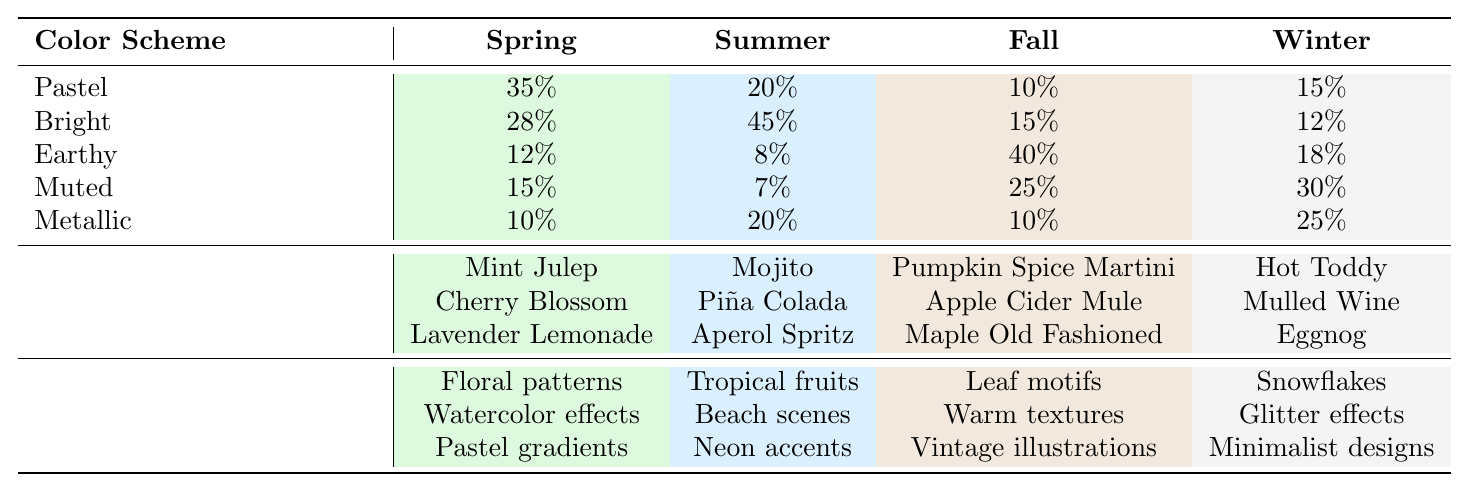What is the most popular color scheme for Spring? The table shows that the "Pastel" color scheme has the highest percentage at 35% for Spring.
Answer: Pastel Which color scheme is least popular in the Summer? From the table, "Muted" is the least popular color scheme with a percentage of 7% for Summer.
Answer: Muted How many total color schemes are represented in the table? There are five color schemes listed: Pastel, Bright, Earthy, Muted, and Metallic. Thus, the total is 5.
Answer: 5 What is the difference in popularity between the Bright color scheme in Summer and Fall? The Bright color scheme is 45% in Summer and 15% in Fall, so the difference is 45 - 15 = 30%.
Answer: 30% What color scheme is the most popular in Winter? According to the table, "Muted" has the highest percentage at 30% in Winter.
Answer: Muted What is the average popularity of the Earthy color scheme across all four seasons? Adding the percentages for Earthy: 12% (Spring) + 8% (Summer) + 40% (Fall) + 18% (Winter) = 78%. Then, dividing by 4 gives an average of 78 / 4 = 19.5%.
Answer: 19.5% Which season has the highest percentage of Bright color schemes and what is that percentage? The table indicates that Summer has the highest percentage of Bright at 45%.
Answer: Summer, 45% Is the Metallic color scheme more popular in Winter than in Spring? In Winter, the Metallic percentage is 25% while in Spring, it is 10%. Since 25% is greater than 10%, the statement is true.
Answer: Yes Which season has the lowest usage of Pastel color schemes and what is the percentage? The table shows that Fall has the lowest usage with only 10% for the Pastel color scheme.
Answer: Fall, 10% If a designer wants to create a cocktail label with the most common design elements for Fall, which design elements should they consider? The table lists the trendy design elements for Fall as "Leaf motifs," "Warm textures," and "Vintage illustrations." Thus, these should be considered.
Answer: Leaf motifs, Warm textures, Vintage illustrations 